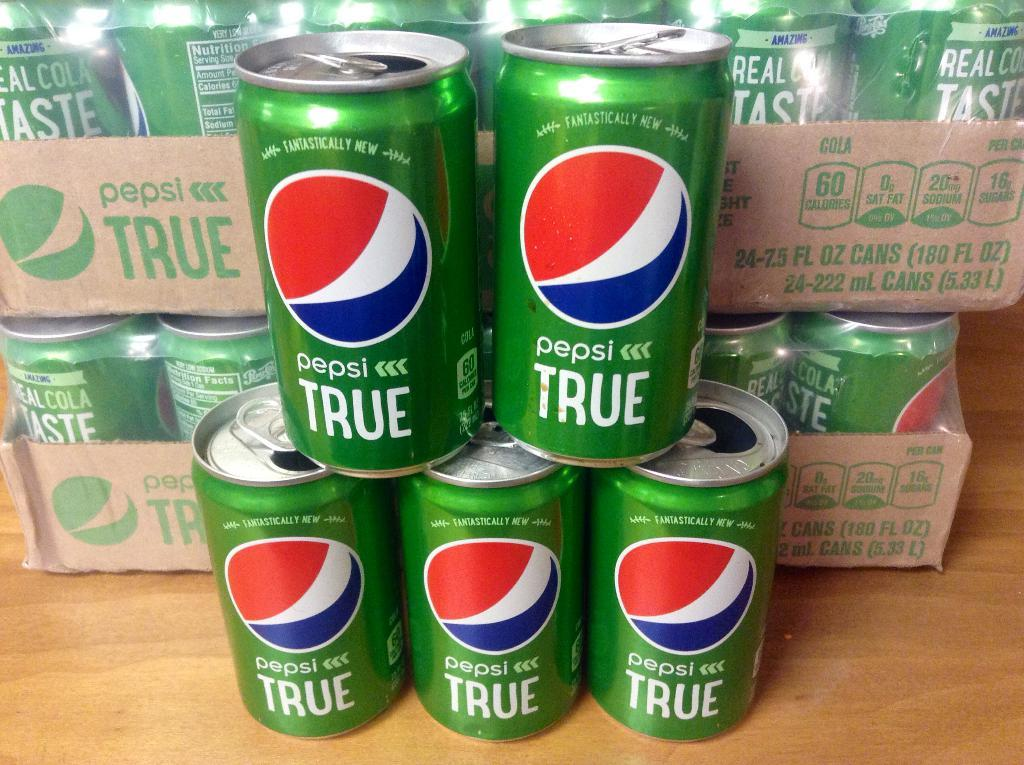<image>
Provide a brief description of the given image. A pyramid of Pepsi True cans with a few cases behind it. 